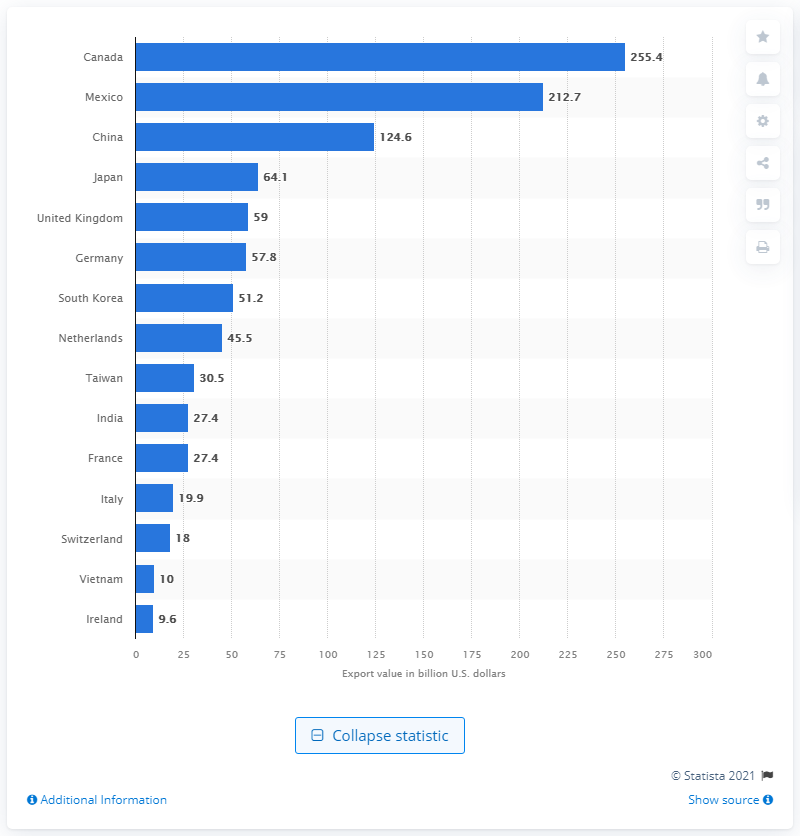List a handful of essential elements in this visual. In 2020, the United States exported approximately 255.4 billion dollars worth of goods to Canada. In 2020, Canada was the top trading partner of the United States. 